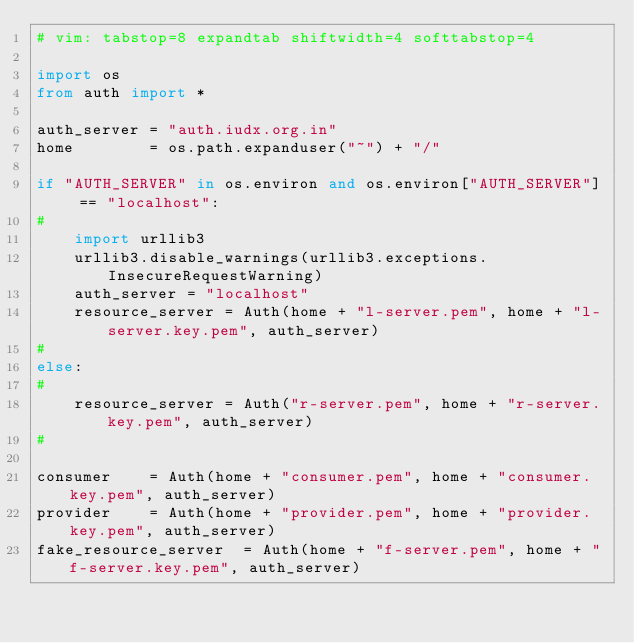Convert code to text. <code><loc_0><loc_0><loc_500><loc_500><_Python_># vim: tabstop=8 expandtab shiftwidth=4 softtabstop=4

import os
from auth import *

auth_server = "auth.iudx.org.in"
home        = os.path.expanduser("~") + "/"

if "AUTH_SERVER" in os.environ and os.environ["AUTH_SERVER"] == "localhost":
#
    import urllib3
    urllib3.disable_warnings(urllib3.exceptions.InsecureRequestWarning)
    auth_server = "localhost"
    resource_server = Auth(home + "l-server.pem", home + "l-server.key.pem", auth_server)
#
else:
#
    resource_server = Auth("r-server.pem", home + "r-server.key.pem", auth_server)
#

consumer		= Auth(home + "consumer.pem", home + "consumer.key.pem", auth_server)
provider		= Auth(home + "provider.pem", home + "provider.key.pem", auth_server)
fake_resource_server	= Auth(home + "f-server.pem", home + "f-server.key.pem", auth_server)
</code> 